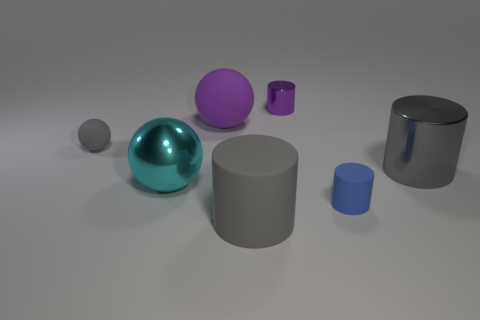There is a cylinder that is behind the cyan thing and in front of the tiny metallic cylinder; what is its material?
Keep it short and to the point. Metal. There is a tiny ball; does it have the same color as the large matte thing that is in front of the gray rubber ball?
Make the answer very short. Yes. What is the size of the gray object that is the same shape as the large cyan object?
Offer a terse response. Small. There is a thing that is both on the left side of the purple cylinder and behind the small gray object; what is its shape?
Give a very brief answer. Sphere. Do the gray metallic cylinder and the blue rubber thing that is to the right of the purple metallic thing have the same size?
Your response must be concise. No. There is a small matte object that is the same shape as the large gray rubber thing; what color is it?
Provide a succinct answer. Blue. There is a gray object that is to the right of the small blue cylinder; does it have the same size as the rubber object on the left side of the cyan sphere?
Your answer should be very brief. No. Is the purple rubber thing the same shape as the big cyan metal thing?
Give a very brief answer. Yes. How many things are either gray metallic things behind the small matte cylinder or purple metallic objects?
Make the answer very short. 2. Is there a rubber object of the same shape as the gray metal thing?
Provide a succinct answer. Yes. 